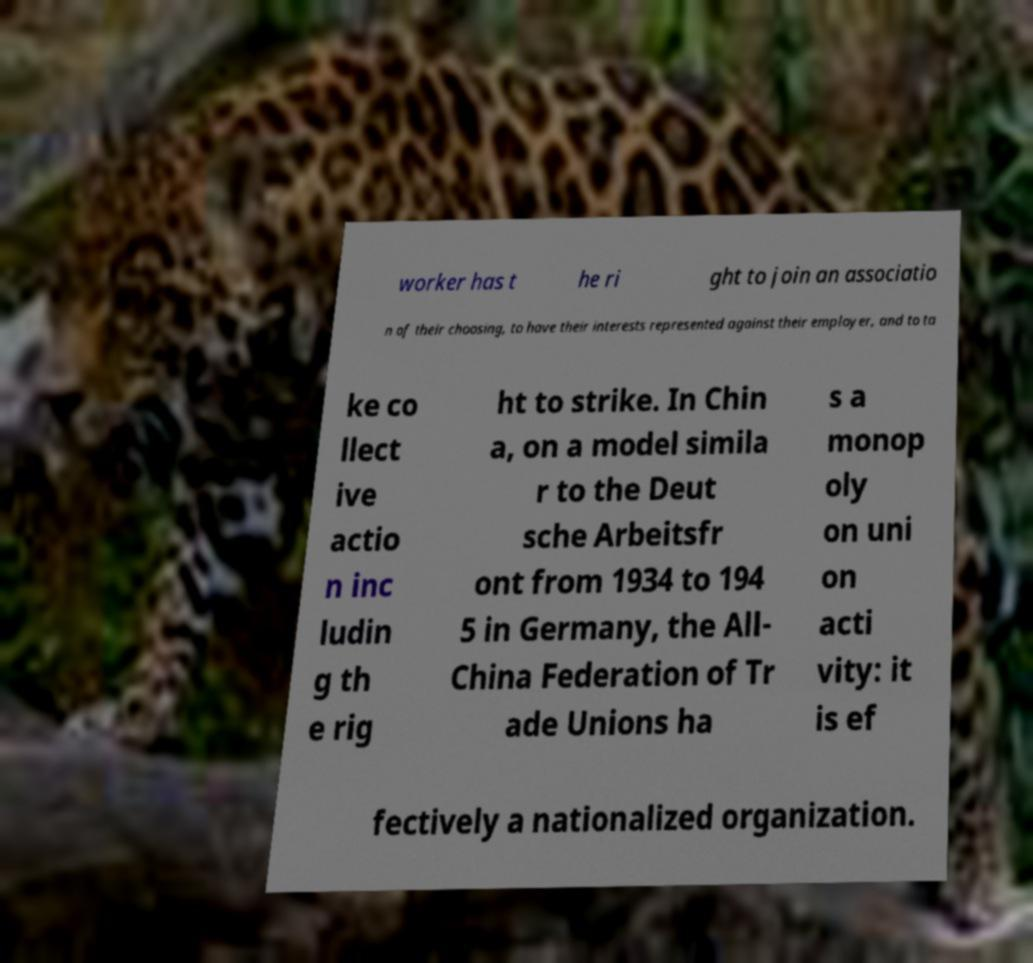For documentation purposes, I need the text within this image transcribed. Could you provide that? worker has t he ri ght to join an associatio n of their choosing, to have their interests represented against their employer, and to ta ke co llect ive actio n inc ludin g th e rig ht to strike. In Chin a, on a model simila r to the Deut sche Arbeitsfr ont from 1934 to 194 5 in Germany, the All- China Federation of Tr ade Unions ha s a monop oly on uni on acti vity: it is ef fectively a nationalized organization. 